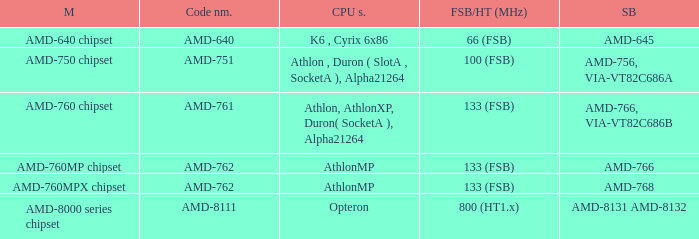For a system with athlon, athlon xp, duron (socket a), and alpha 21264 cpu support, what was the corresponding southbridge? AMD-766, VIA-VT82C686B. 